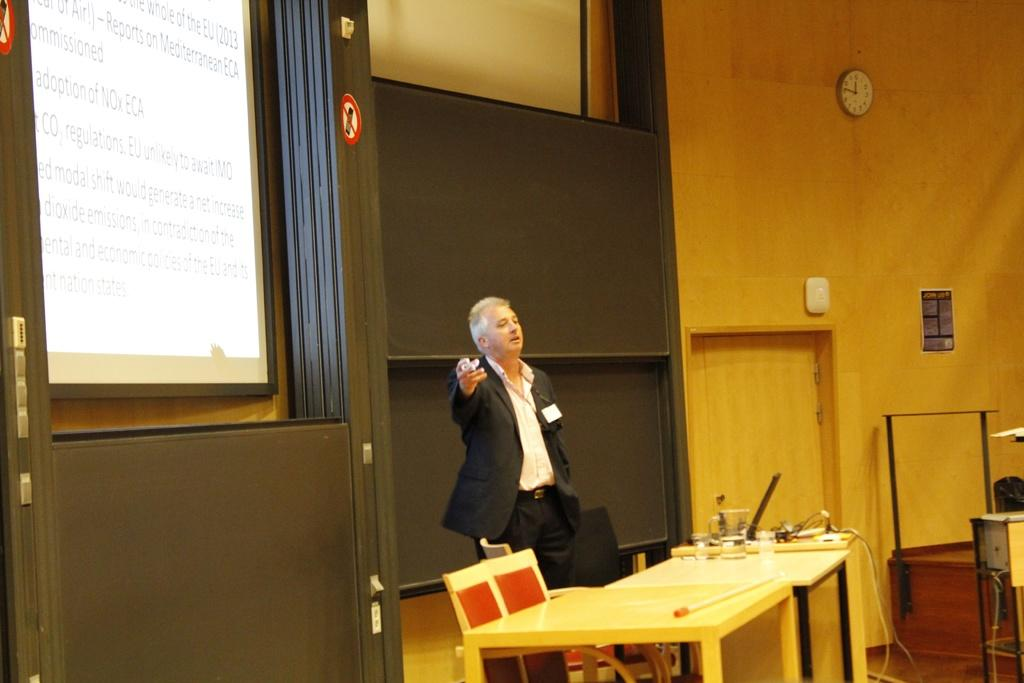What is the main subject in the image? There is a man standing in the image. What objects can be seen in the room? There is a table, a glass, a chair, a screen, a wall, a clock, and a poster in the image. Can you describe the wall in the image? There is a clock and a poster on the wall in the image. What is the purpose of the glass? The purpose of the glass is not clear from the image alone. What type of badge is the man wearing in the image? There is no mention of a badge in the provided facts, so it cannot be determined from the image. 